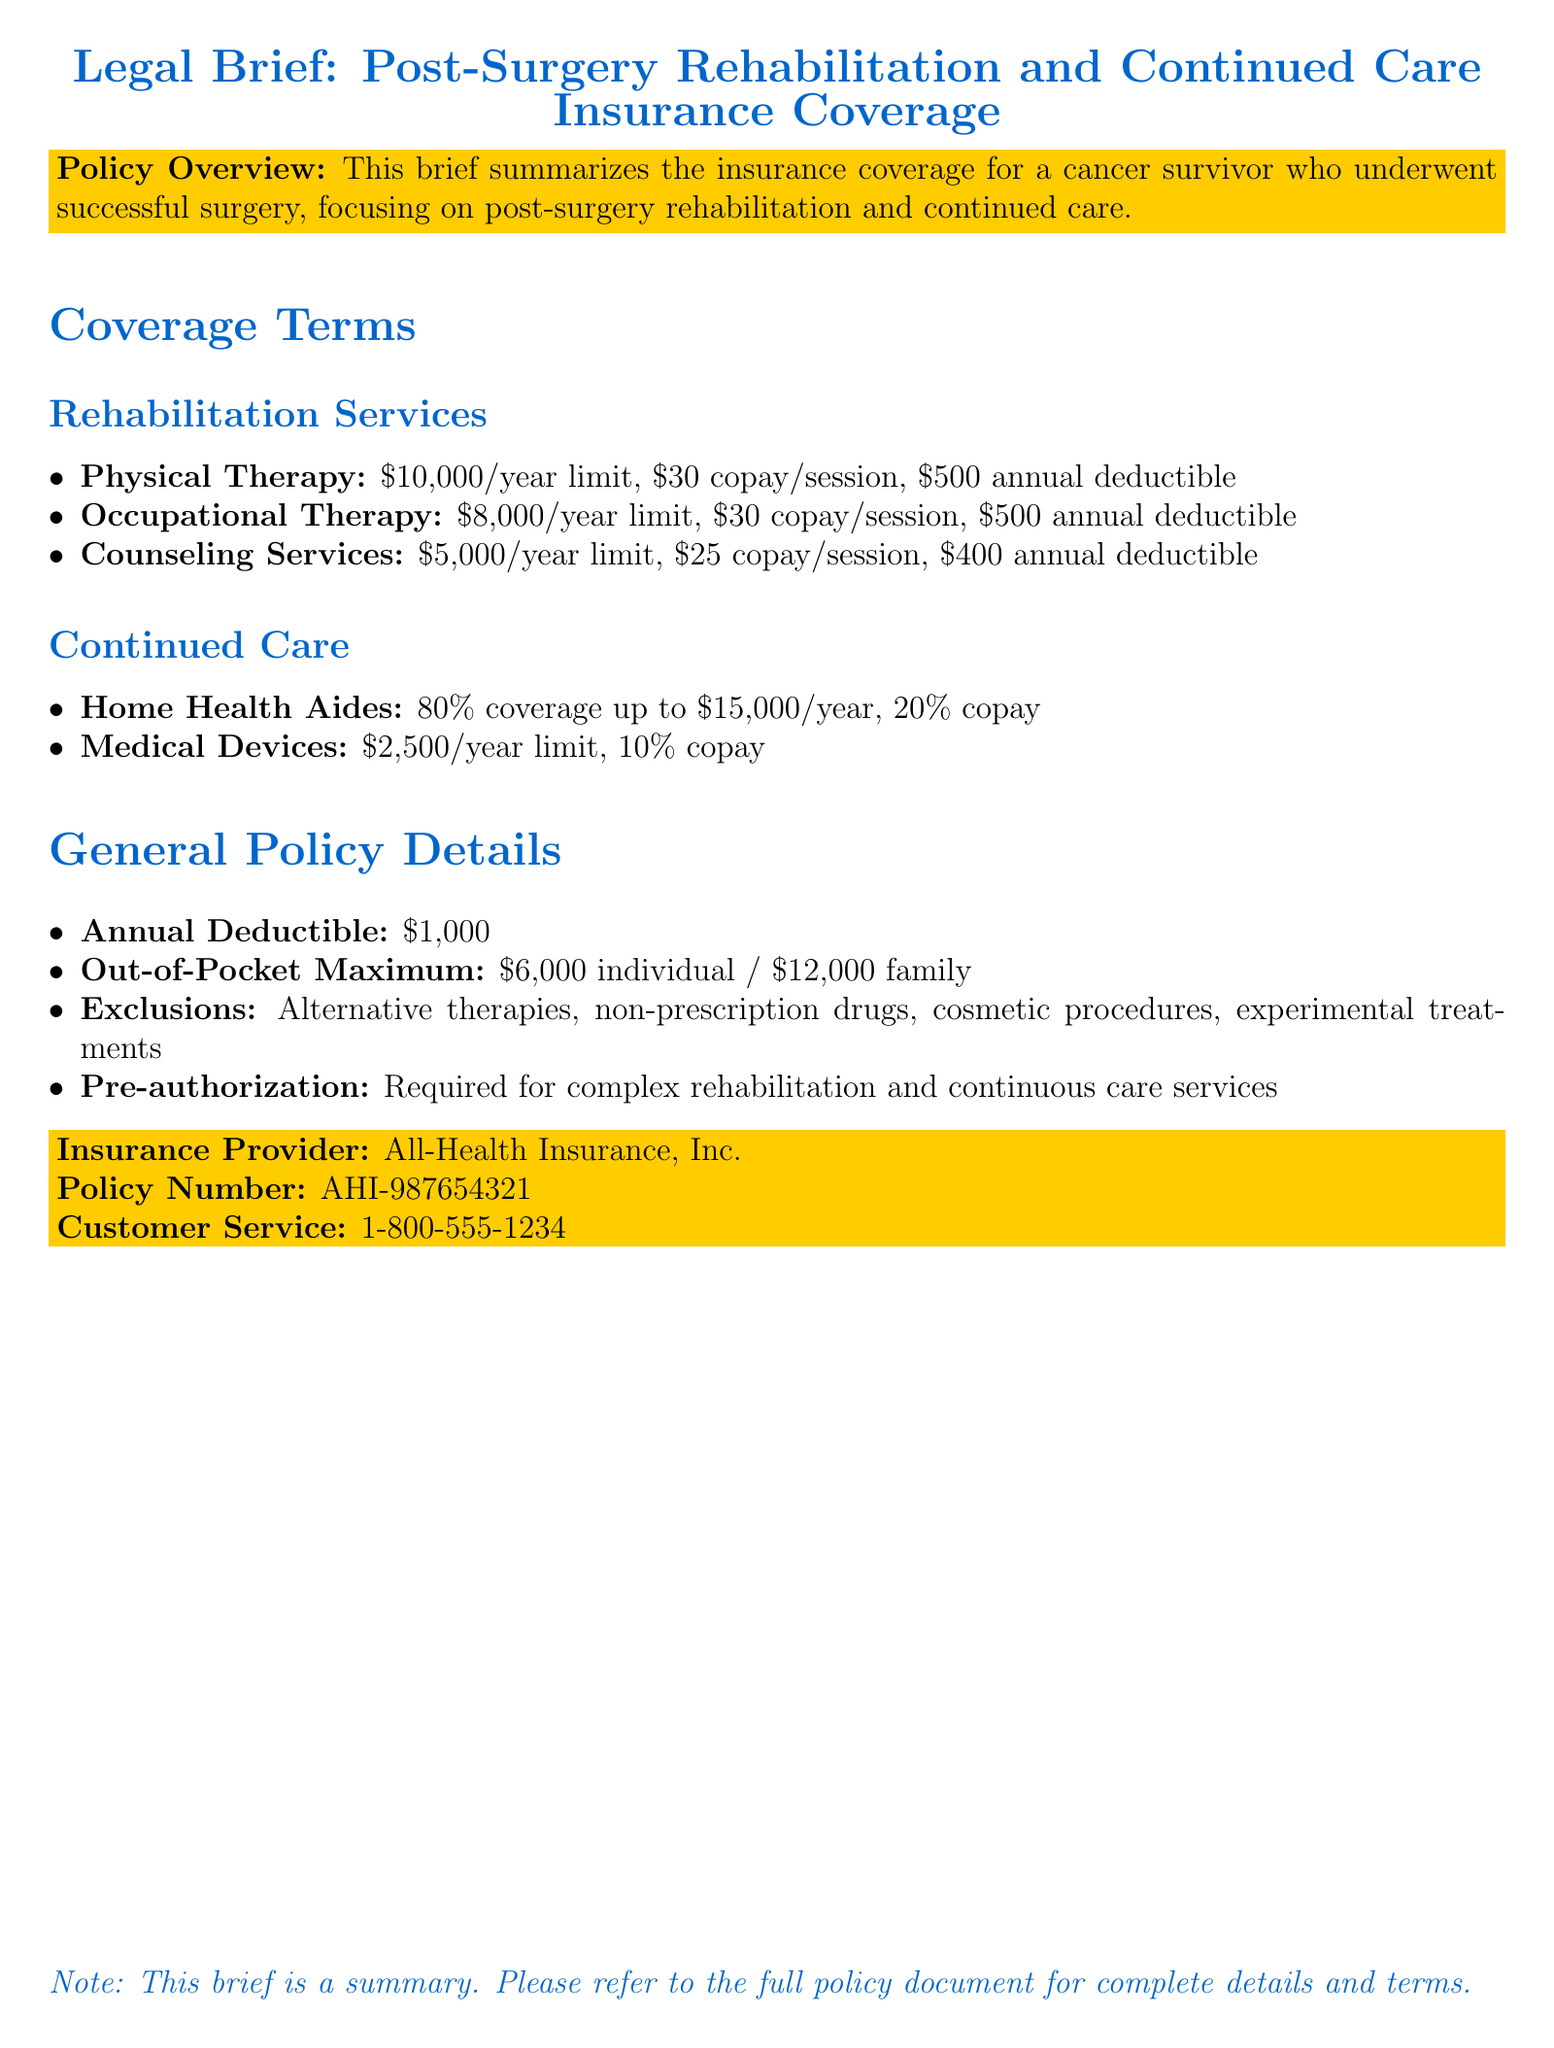what is the annual limit for physical therapy? The document states the annual limit for physical therapy is $10,000.
Answer: $10,000 what is the copay for counseling services? According to the brief, the copay for counseling services is $25 per session.
Answer: $25 what is the coverage percentage for home health aides? The document indicates that the coverage for home health aides is 80%.
Answer: 80% what is the out-of-pocket maximum for an individual? The out-of-pocket maximum listed for an individual is $6,000.
Answer: $6,000 which services require pre-authorization? The brief mentions that complex rehabilitation and continuous care services require pre-authorization.
Answer: complex rehabilitation and continuous care services what is excluded from coverage? The document lists alternative therapies, non-prescription drugs, cosmetic procedures, and experimental treatments as exclusions.
Answer: alternative therapies, non-prescription drugs, cosmetic procedures, experimental treatments what is the annual deductible stated in the policy? The annual deductible mentioned is $1,000.
Answer: $1,000 what is the limit for medical devices coverage? The coverage limit for medical devices is noted as $2,500 per year.
Answer: $2,500 